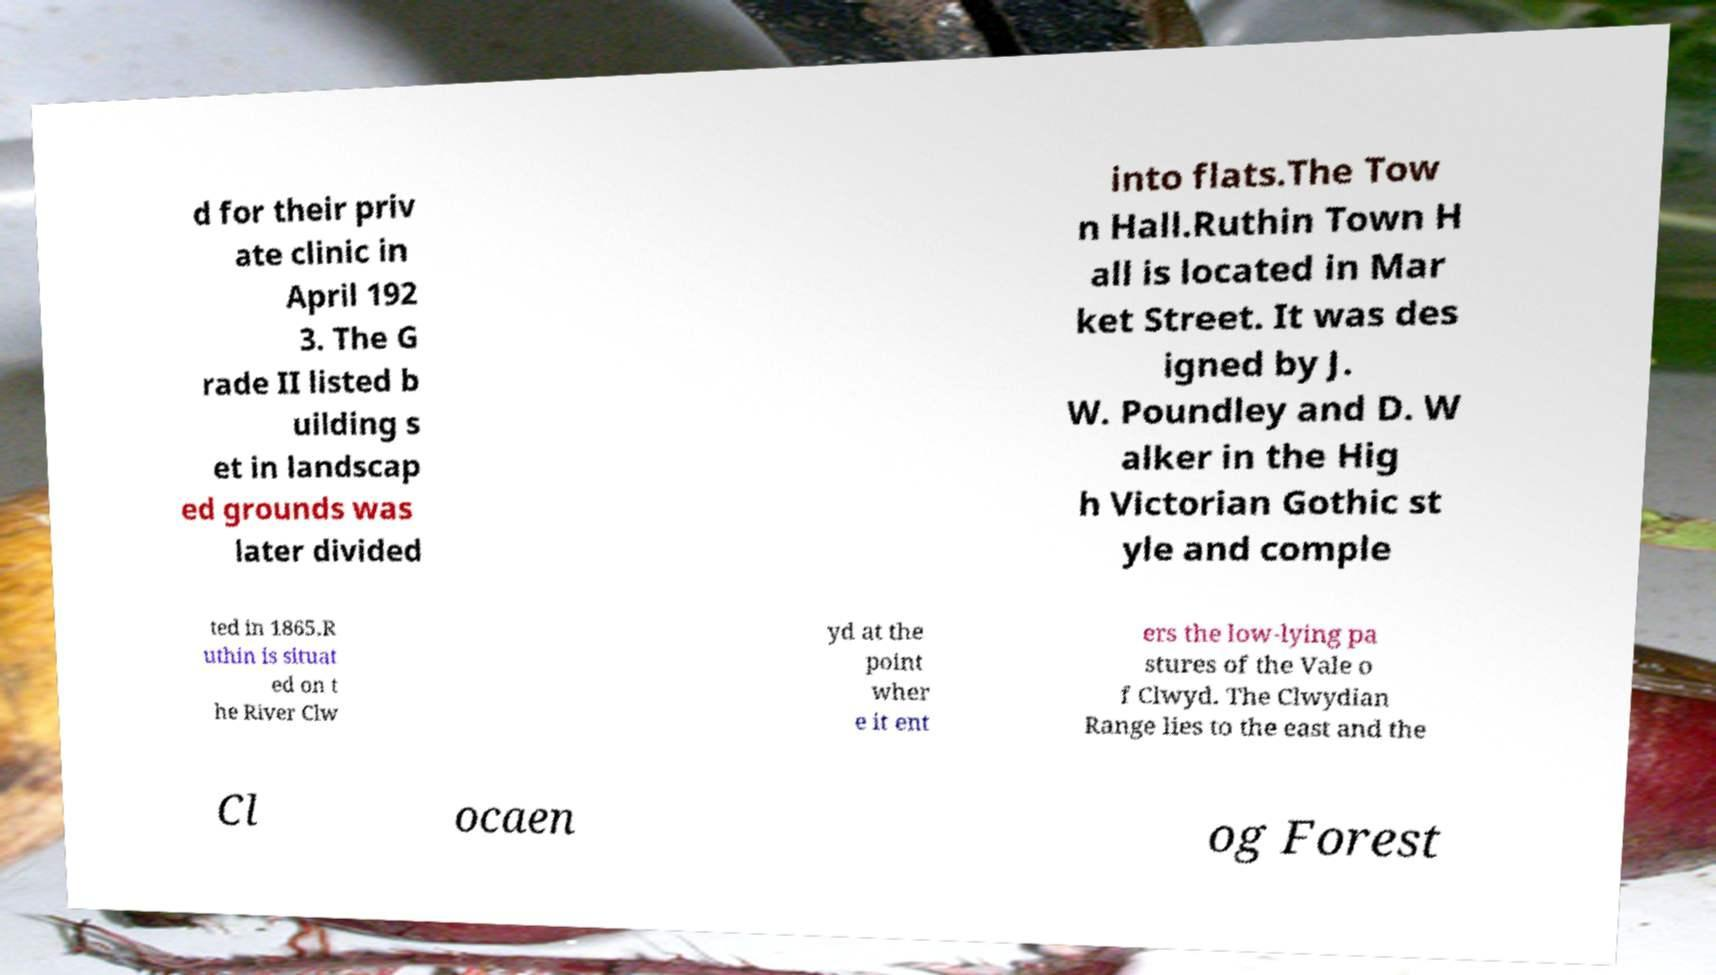Could you assist in decoding the text presented in this image and type it out clearly? d for their priv ate clinic in April 192 3. The G rade II listed b uilding s et in landscap ed grounds was later divided into flats.The Tow n Hall.Ruthin Town H all is located in Mar ket Street. It was des igned by J. W. Poundley and D. W alker in the Hig h Victorian Gothic st yle and comple ted in 1865.R uthin is situat ed on t he River Clw yd at the point wher e it ent ers the low-lying pa stures of the Vale o f Clwyd. The Clwydian Range lies to the east and the Cl ocaen og Forest 